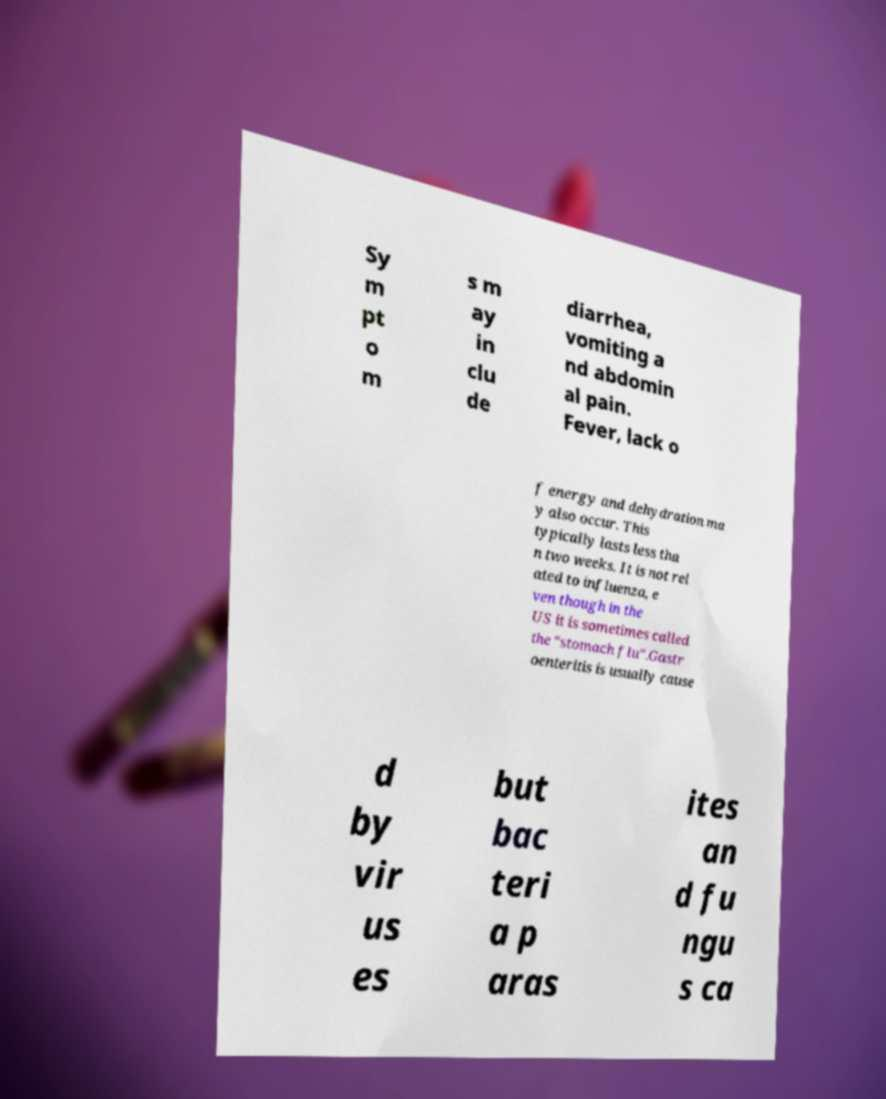Can you read and provide the text displayed in the image?This photo seems to have some interesting text. Can you extract and type it out for me? Sy m pt o m s m ay in clu de diarrhea, vomiting a nd abdomin al pain. Fever, lack o f energy and dehydration ma y also occur. This typically lasts less tha n two weeks. It is not rel ated to influenza, e ven though in the US it is sometimes called the "stomach flu".Gastr oenteritis is usually cause d by vir us es but bac teri a p aras ites an d fu ngu s ca 